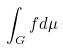<formula> <loc_0><loc_0><loc_500><loc_500>\int _ { G } f d \mu</formula> 